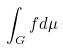<formula> <loc_0><loc_0><loc_500><loc_500>\int _ { G } f d \mu</formula> 